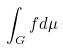<formula> <loc_0><loc_0><loc_500><loc_500>\int _ { G } f d \mu</formula> 